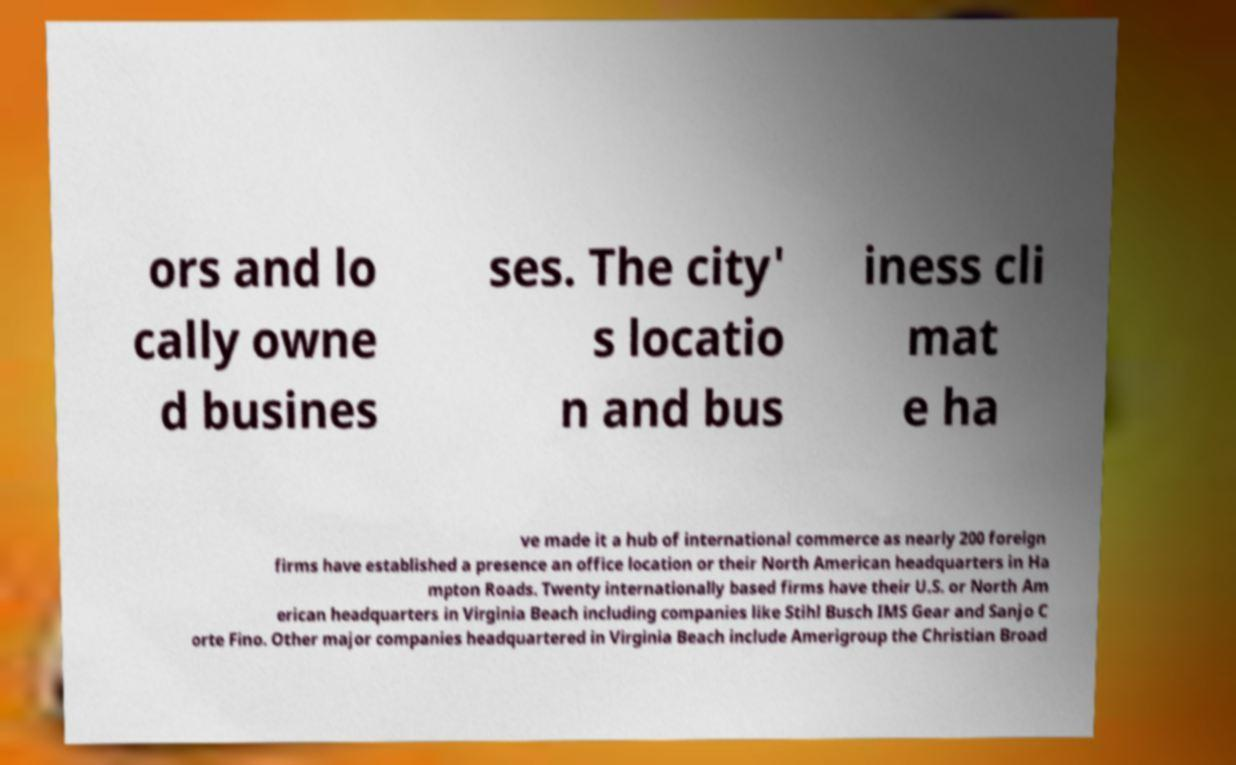What messages or text are displayed in this image? I need them in a readable, typed format. ors and lo cally owne d busines ses. The city' s locatio n and bus iness cli mat e ha ve made it a hub of international commerce as nearly 200 foreign firms have established a presence an office location or their North American headquarters in Ha mpton Roads. Twenty internationally based firms have their U.S. or North Am erican headquarters in Virginia Beach including companies like Stihl Busch IMS Gear and Sanjo C orte Fino. Other major companies headquartered in Virginia Beach include Amerigroup the Christian Broad 